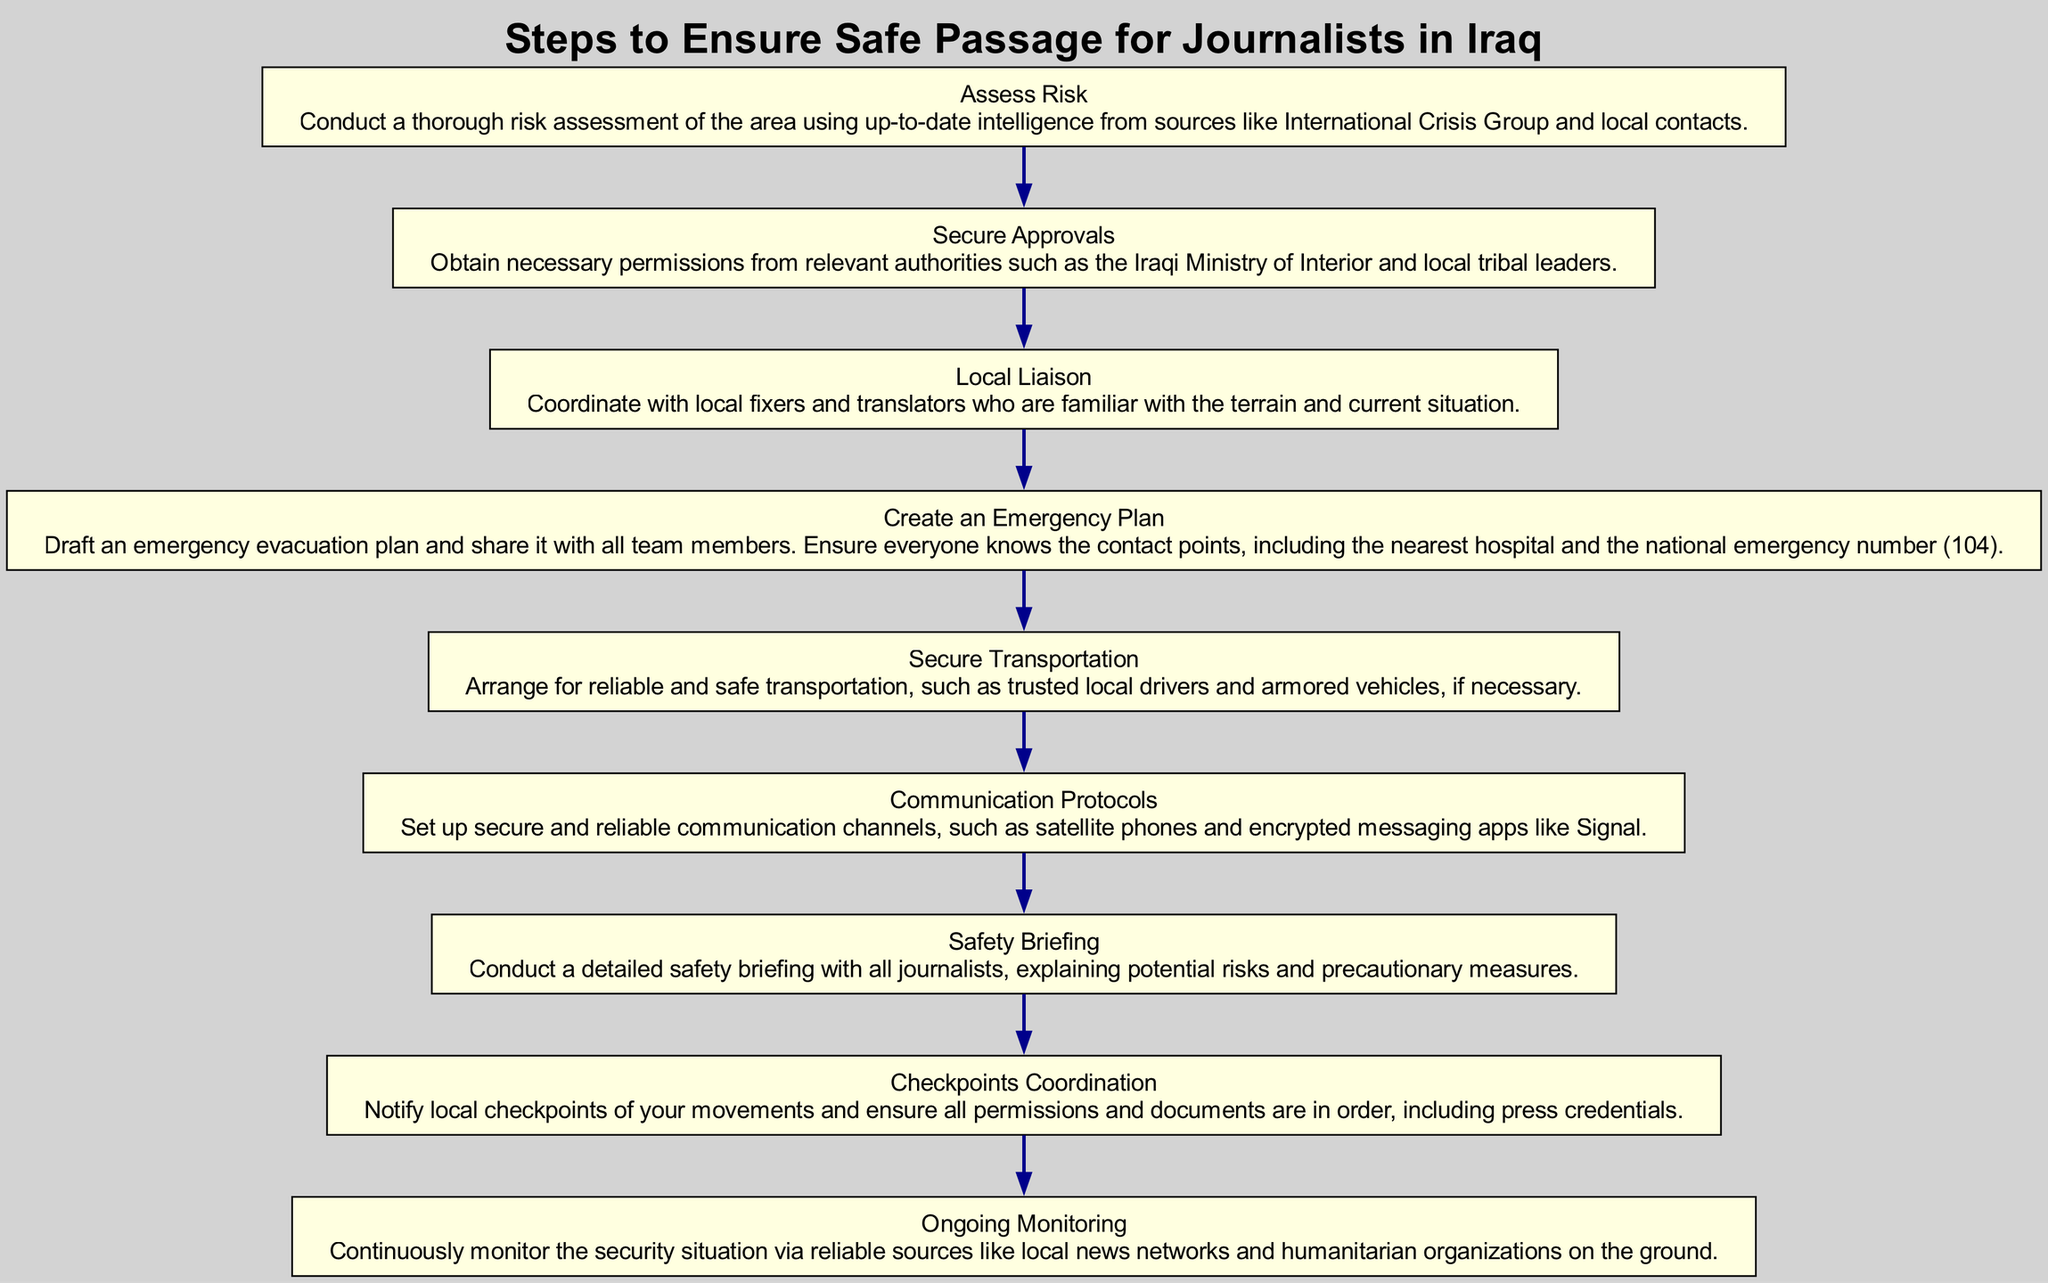What is the first step in the flow chart? The first step listed in the diagram is "Assess Risk." This is indicated as the topmost node in the flow chart, which outlines the initial action before any other steps are taken.
Answer: Assess Risk How many total steps are there in the flow chart? The diagram contains a total of nine distinct steps, each represented as a separate node connected in sequential order.
Answer: 9 Which step focuses on communication methods? The step titled "Communication Protocols" addresses the need for secure communication methods, detailing specific channels to be used.
Answer: Communication Protocols What does the "Local Liaison" step involve? "Local Liaison" involves coordinating with local fixers and translators who are knowledgeable about the area's conditions, ensuring that the reporting team is well-informed and prepared.
Answer: Coordinate with local fixers and translators Which step comes right before creating an emergency plan? The step that precedes "Create an Emergency Plan" is "Local Liaison." This indicates the sequence of actions with "Local Liaison" being a crucial part before planning for emergency procedures.
Answer: Local Liaison Which authority is mentioned for securing approvals? The diagram states that necessary permissions should be obtained from the "Iraqi Ministry of Interior" among possibly other local authorities, as part of the approval process.
Answer: Iraqi Ministry of Interior What is the final step according to the flow chart? The last step in the chart is "Ongoing Monitoring," which involves keeping track of the current security situation as it continues to unfold in the area.
Answer: Ongoing Monitoring What is a key detail regarding transportation in the flow chart? The step "Secure Transportation" emphasizes the importance of arranging reliable and safe transportation, specifically mentioning the use of trusted local drivers and armored vehicles if needed.
Answer: Arrange for reliable and safe transportation What must journalists be informed about during the safety briefing? During the "Safety Briefing," journalists must be informed about potential risks and precautionary measures, ensuring they are well-prepared for the situation they may face.
Answer: Potential risks and precautionary measures 